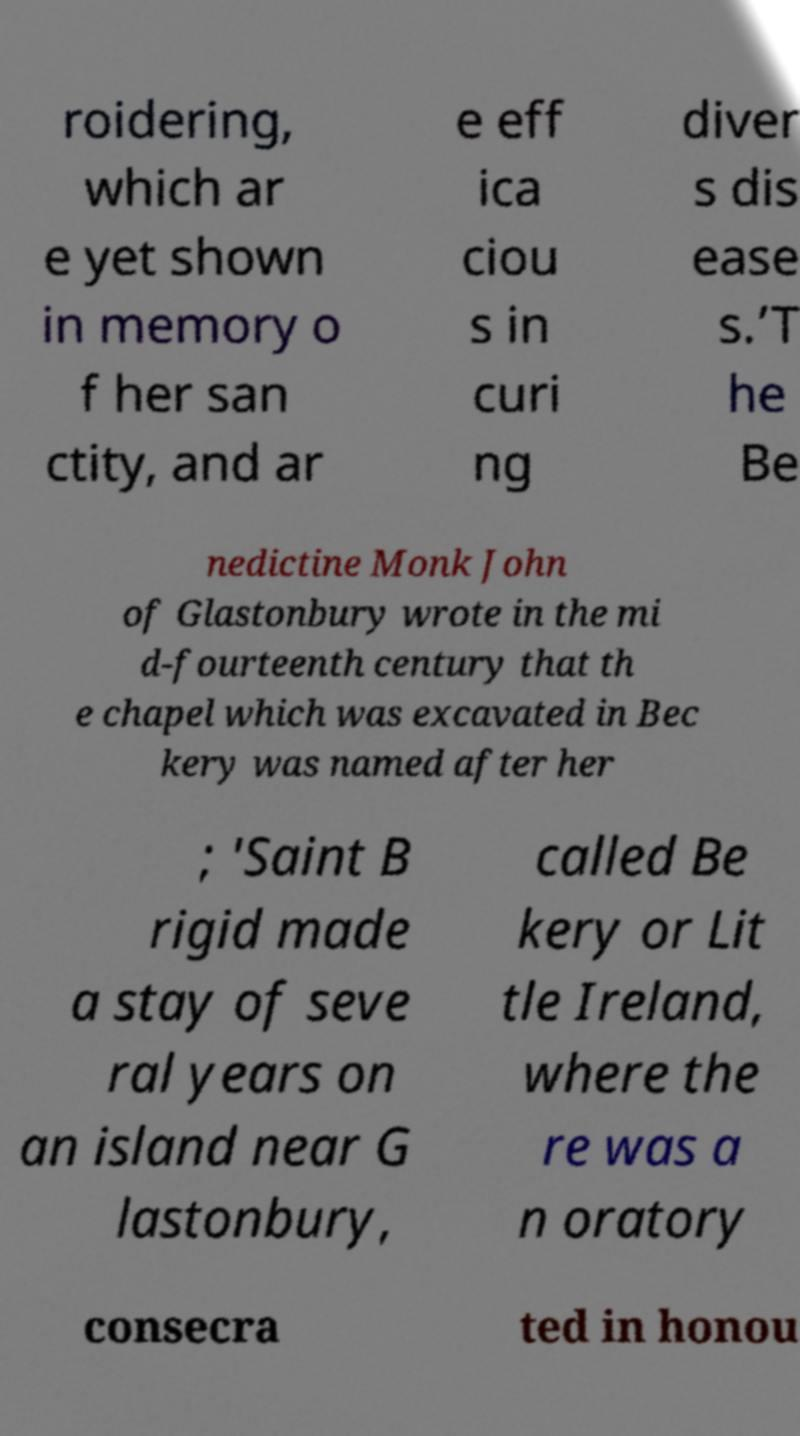Can you read and provide the text displayed in the image?This photo seems to have some interesting text. Can you extract and type it out for me? roidering, which ar e yet shown in memory o f her san ctity, and ar e eff ica ciou s in curi ng diver s dis ease s.’T he Be nedictine Monk John of Glastonbury wrote in the mi d-fourteenth century that th e chapel which was excavated in Bec kery was named after her ; 'Saint B rigid made a stay of seve ral years on an island near G lastonbury, called Be kery or Lit tle Ireland, where the re was a n oratory consecra ted in honou 